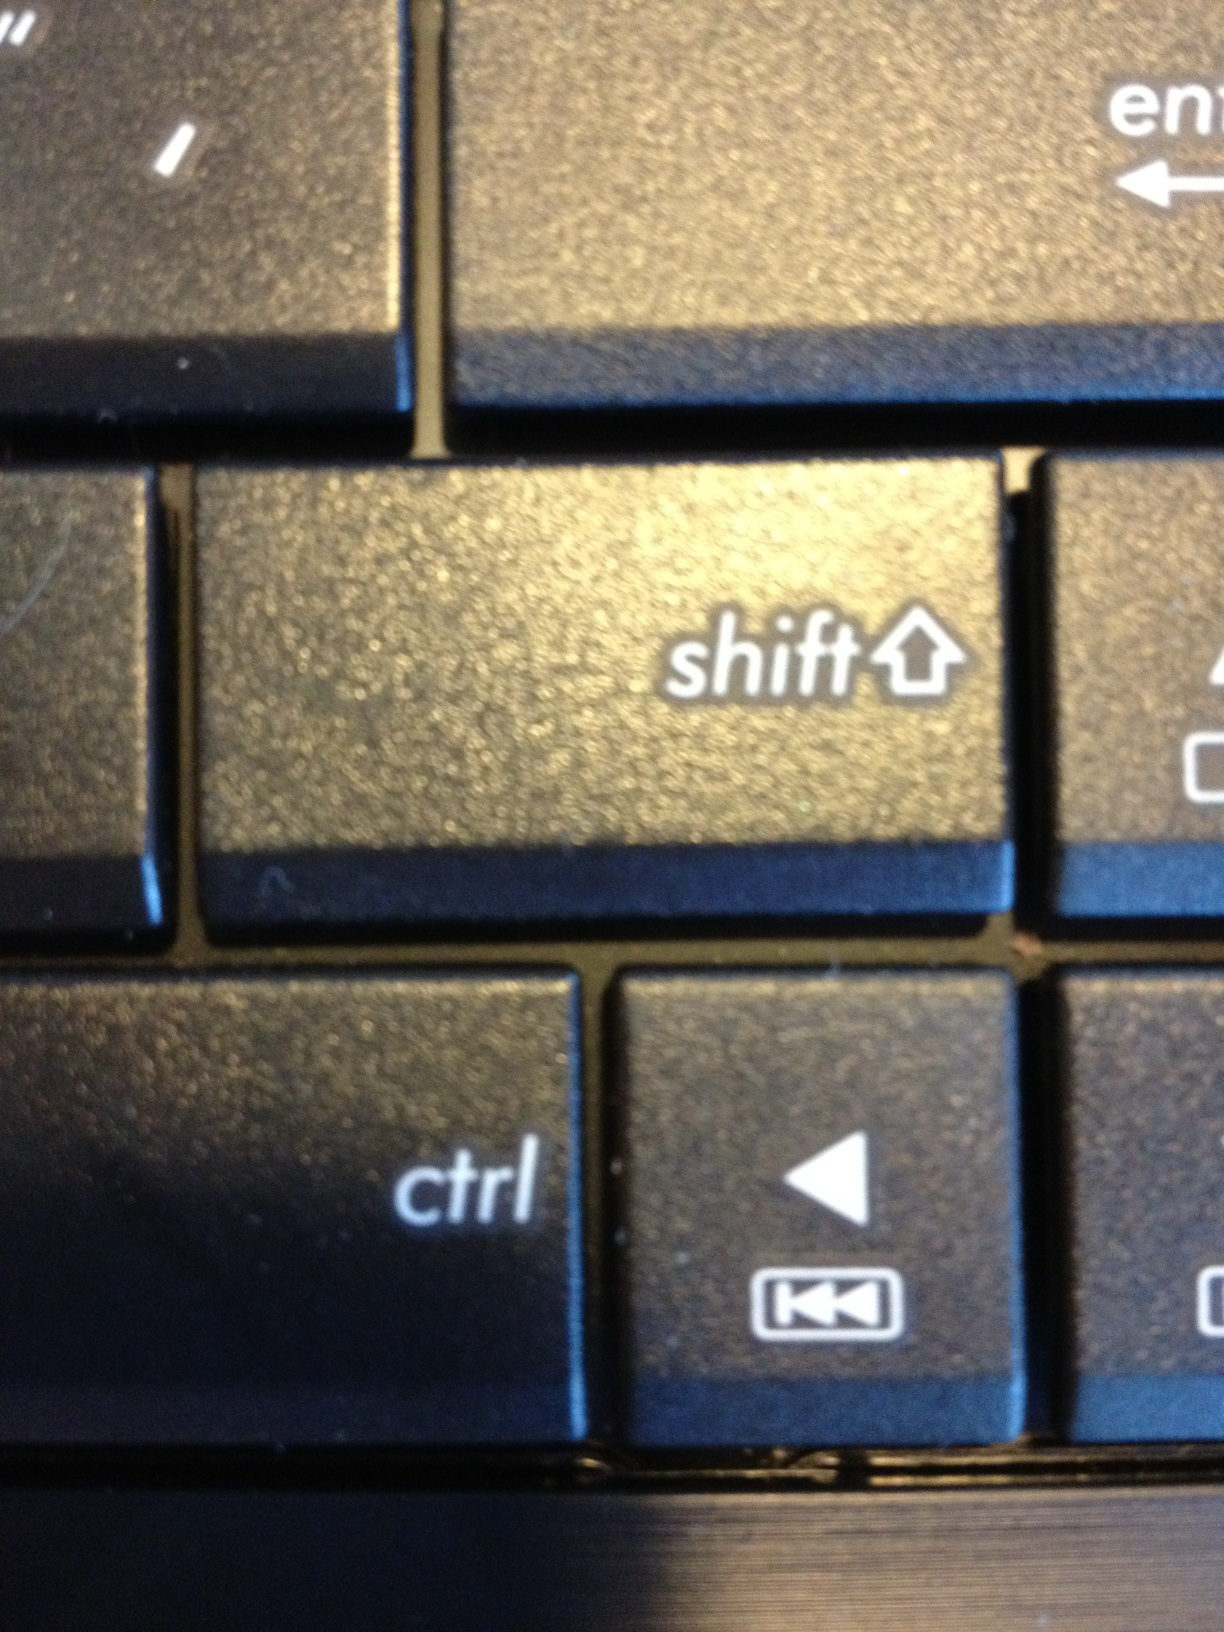What does this say? The image depicts a close-up view of a portion of a computer keyboard focusing on the 'Shift' and 'Ctrl' keys, also showing partial views of the 'Enter' key above the 'Shift' and the 'Backtrack' navigation key to the right of 'Ctrl'. The keys are black with white lettering. 